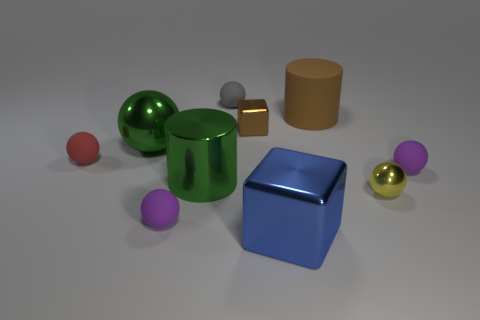Is the metallic cylinder the same color as the large metallic block?
Provide a succinct answer. No. Is the number of small red rubber cylinders greater than the number of big brown things?
Make the answer very short. No. What number of other things are there of the same material as the red object
Your answer should be compact. 4. What number of things are big gray metal things or blue metallic objects in front of the big brown cylinder?
Ensure brevity in your answer.  1. Are there fewer small brown things than spheres?
Your answer should be very brief. Yes. What color is the metallic cube that is behind the tiny metallic thing in front of the green object in front of the red rubber sphere?
Ensure brevity in your answer.  Brown. Are the small red ball and the gray object made of the same material?
Keep it short and to the point. Yes. What number of large cylinders are on the left side of the big brown rubber object?
Your answer should be very brief. 1. What size is the green thing that is the same shape as the small gray matte thing?
Ensure brevity in your answer.  Large. How many red objects are cylinders or shiny cylinders?
Provide a succinct answer. 0. 